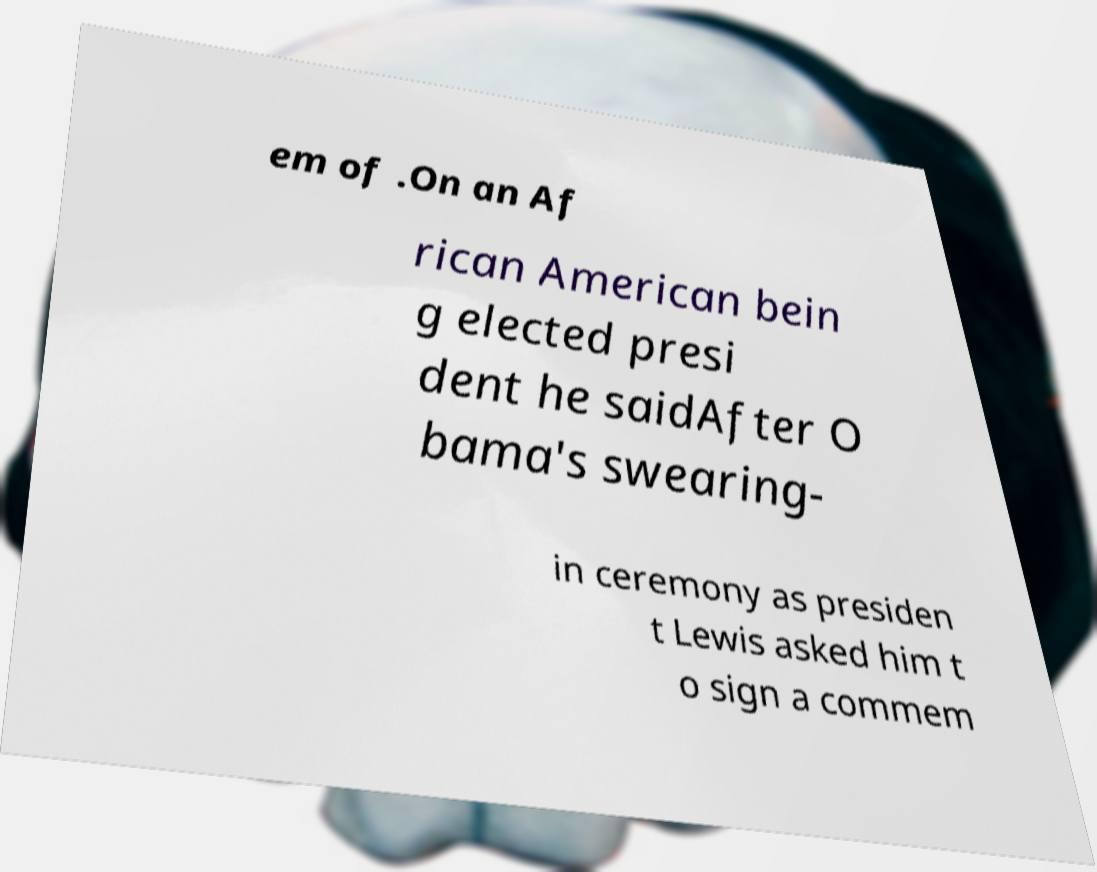Can you accurately transcribe the text from the provided image for me? em of .On an Af rican American bein g elected presi dent he saidAfter O bama's swearing- in ceremony as presiden t Lewis asked him t o sign a commem 